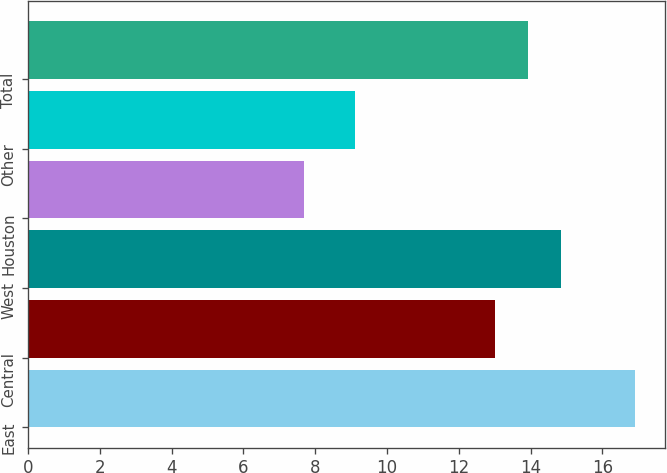<chart> <loc_0><loc_0><loc_500><loc_500><bar_chart><fcel>East<fcel>Central<fcel>West<fcel>Houston<fcel>Other<fcel>Total<nl><fcel>16.9<fcel>13<fcel>14.84<fcel>7.7<fcel>9.1<fcel>13.92<nl></chart> 